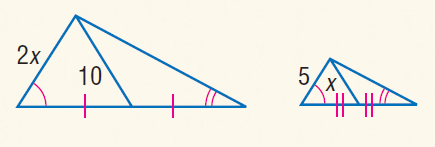Answer the mathemtical geometry problem and directly provide the correct option letter.
Question: Find x.
Choices: A: 5 B: 7.5 C: 10 D: 12.5 A 